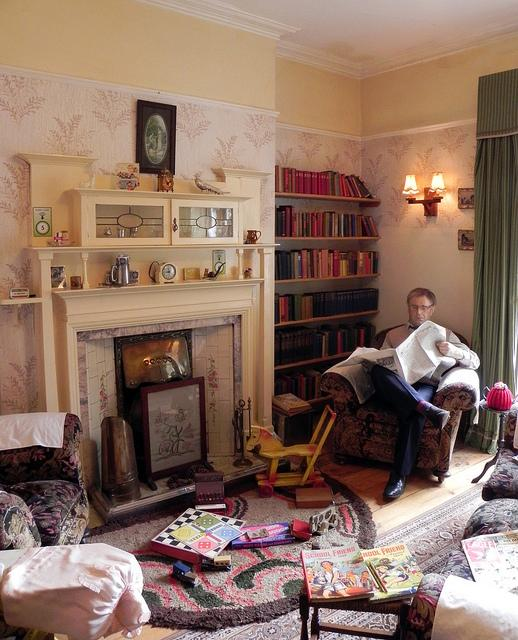How is the game laying on top of the chess board called? Please explain your reasoning. ludo. The game is known as ludo. 